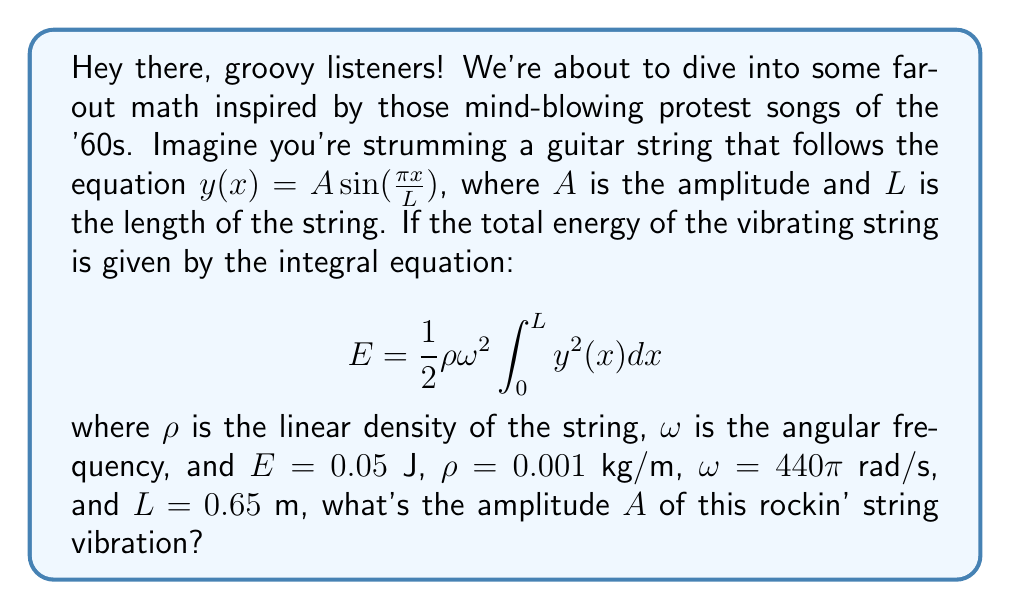Could you help me with this problem? Alright, let's break this down step by step:

1) We start with the given equation for the string's shape:
   $y(x) = A \sin(\frac{\pi x}{L})$

2) We need to square this function for the integral:
   $y^2(x) = A^2 \sin^2(\frac{\pi x}{L})$

3) Now, let's substitute this into our energy equation:
   $$ E = \frac{1}{2}\rho\omega^2 \int_0^L A^2 \sin^2(\frac{\pi x}{L}) dx $$

4) We can pull the constants out of the integral:
   $$ E = \frac{1}{2}\rho\omega^2 A^2 \int_0^L \sin^2(\frac{\pi x}{L}) dx $$

5) The integral of $\sin^2$ over a full period is $\frac{L}{2}$, so:
   $$ E = \frac{1}{2}\rho\omega^2 A^2 \cdot \frac{L}{2} = \frac{1}{4}\rho\omega^2 A^2 L $$

6) Now, let's substitute the known values:
   $$ 0.05 = \frac{1}{4} \cdot 0.001 \cdot (440\pi)^2 \cdot A^2 \cdot 0.65 $$

7) Simplify:
   $$ 0.05 = 62,436.905 \cdot A^2 $$

8) Solve for $A$:
   $$ A^2 = \frac{0.05}{62,436.905} $$
   $$ A = \sqrt{\frac{0.05}{62,436.905}} \approx 0.0008944 $$

Therefore, the amplitude $A$ is approximately 0.0008944 meters or 0.8944 millimeters.
Answer: $A \approx 0.8944$ mm 